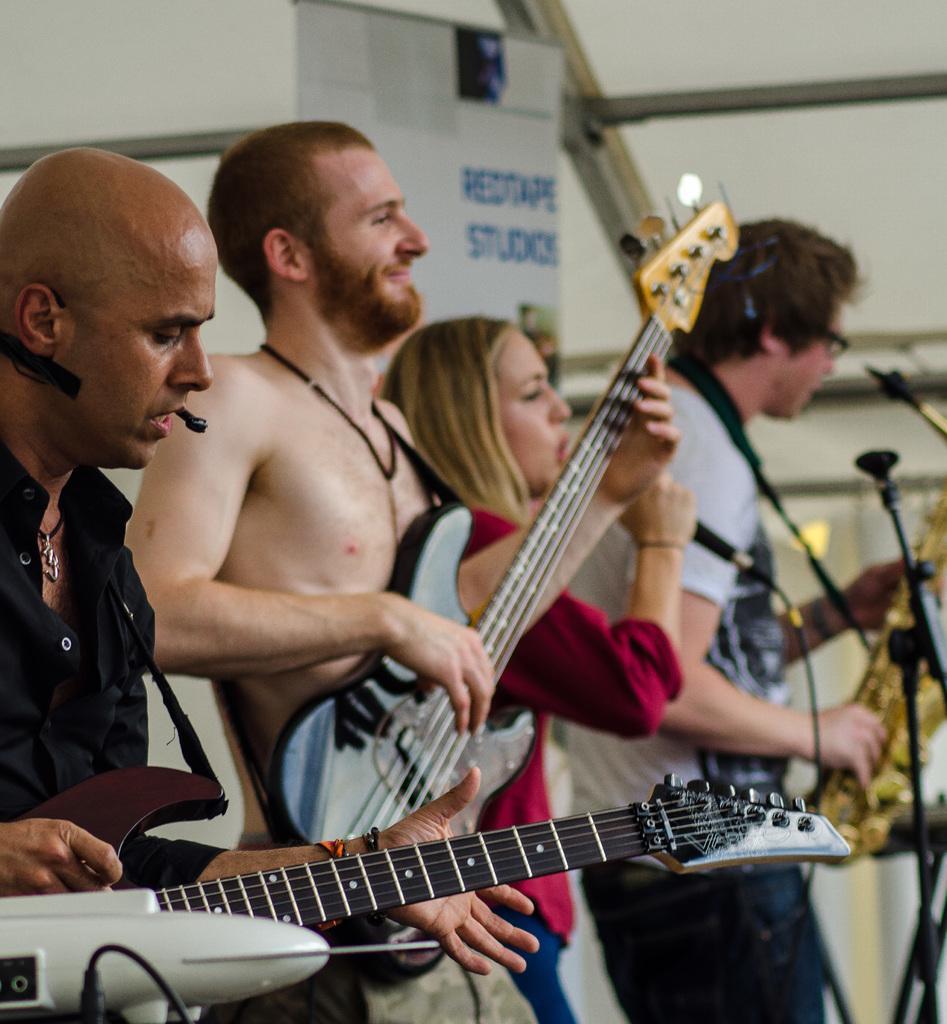Describe this image in one or two sentences. This image has three men and one woman standing. The person at the left side is holding a guitar, wearing a black shirt. Woman is wearing a pink shirt, blue jeans. The person at the right side is playing a saxophone wearing a white shirt. 